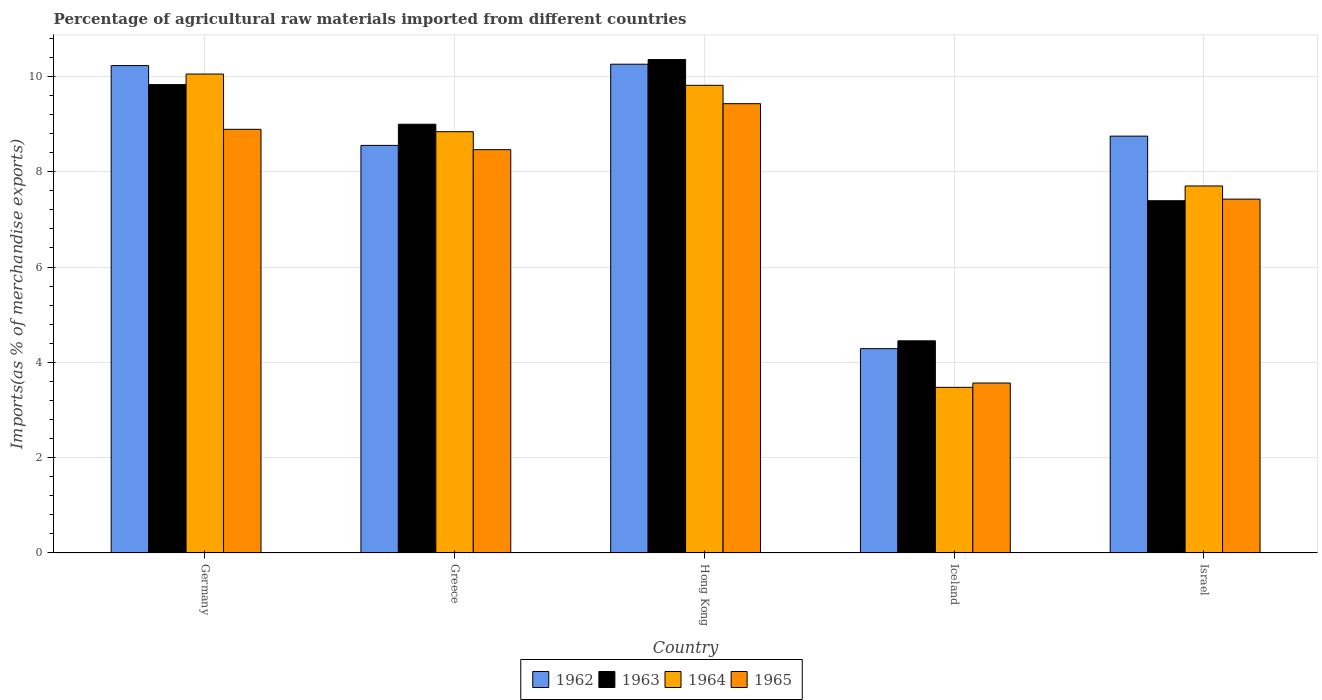How many groups of bars are there?
Keep it short and to the point. 5. How many bars are there on the 5th tick from the left?
Give a very brief answer. 4. What is the percentage of imports to different countries in 1964 in Israel?
Give a very brief answer. 7.7. Across all countries, what is the maximum percentage of imports to different countries in 1963?
Keep it short and to the point. 10.35. Across all countries, what is the minimum percentage of imports to different countries in 1965?
Provide a succinct answer. 3.57. In which country was the percentage of imports to different countries in 1965 maximum?
Keep it short and to the point. Hong Kong. What is the total percentage of imports to different countries in 1964 in the graph?
Keep it short and to the point. 39.88. What is the difference between the percentage of imports to different countries in 1965 in Greece and that in Iceland?
Offer a very short reply. 4.9. What is the difference between the percentage of imports to different countries in 1962 in Israel and the percentage of imports to different countries in 1964 in Hong Kong?
Provide a short and direct response. -1.07. What is the average percentage of imports to different countries in 1963 per country?
Offer a terse response. 8.2. What is the difference between the percentage of imports to different countries of/in 1962 and percentage of imports to different countries of/in 1964 in Germany?
Your answer should be compact. 0.18. What is the ratio of the percentage of imports to different countries in 1963 in Germany to that in Hong Kong?
Ensure brevity in your answer.  0.95. Is the difference between the percentage of imports to different countries in 1962 in Greece and Hong Kong greater than the difference between the percentage of imports to different countries in 1964 in Greece and Hong Kong?
Offer a very short reply. No. What is the difference between the highest and the second highest percentage of imports to different countries in 1964?
Offer a very short reply. -0.97. What is the difference between the highest and the lowest percentage of imports to different countries in 1962?
Make the answer very short. 5.97. In how many countries, is the percentage of imports to different countries in 1965 greater than the average percentage of imports to different countries in 1965 taken over all countries?
Provide a short and direct response. 3. Is the sum of the percentage of imports to different countries in 1965 in Greece and Hong Kong greater than the maximum percentage of imports to different countries in 1962 across all countries?
Give a very brief answer. Yes. Is it the case that in every country, the sum of the percentage of imports to different countries in 1965 and percentage of imports to different countries in 1962 is greater than the percentage of imports to different countries in 1963?
Provide a succinct answer. Yes. What is the title of the graph?
Offer a terse response. Percentage of agricultural raw materials imported from different countries. Does "1962" appear as one of the legend labels in the graph?
Your answer should be compact. Yes. What is the label or title of the X-axis?
Offer a terse response. Country. What is the label or title of the Y-axis?
Give a very brief answer. Imports(as % of merchandise exports). What is the Imports(as % of merchandise exports) in 1962 in Germany?
Keep it short and to the point. 10.23. What is the Imports(as % of merchandise exports) of 1963 in Germany?
Ensure brevity in your answer.  9.83. What is the Imports(as % of merchandise exports) of 1964 in Germany?
Provide a short and direct response. 10.05. What is the Imports(as % of merchandise exports) in 1965 in Germany?
Offer a very short reply. 8.89. What is the Imports(as % of merchandise exports) in 1962 in Greece?
Your answer should be very brief. 8.55. What is the Imports(as % of merchandise exports) of 1963 in Greece?
Keep it short and to the point. 9. What is the Imports(as % of merchandise exports) of 1964 in Greece?
Offer a terse response. 8.84. What is the Imports(as % of merchandise exports) of 1965 in Greece?
Make the answer very short. 8.46. What is the Imports(as % of merchandise exports) in 1962 in Hong Kong?
Provide a succinct answer. 10.26. What is the Imports(as % of merchandise exports) in 1963 in Hong Kong?
Provide a succinct answer. 10.35. What is the Imports(as % of merchandise exports) in 1964 in Hong Kong?
Offer a terse response. 9.81. What is the Imports(as % of merchandise exports) in 1965 in Hong Kong?
Your answer should be compact. 9.43. What is the Imports(as % of merchandise exports) in 1962 in Iceland?
Your response must be concise. 4.29. What is the Imports(as % of merchandise exports) of 1963 in Iceland?
Offer a very short reply. 4.45. What is the Imports(as % of merchandise exports) of 1964 in Iceland?
Provide a succinct answer. 3.48. What is the Imports(as % of merchandise exports) in 1965 in Iceland?
Offer a very short reply. 3.57. What is the Imports(as % of merchandise exports) of 1962 in Israel?
Offer a very short reply. 8.75. What is the Imports(as % of merchandise exports) of 1963 in Israel?
Offer a terse response. 7.39. What is the Imports(as % of merchandise exports) in 1964 in Israel?
Your answer should be compact. 7.7. What is the Imports(as % of merchandise exports) in 1965 in Israel?
Ensure brevity in your answer.  7.42. Across all countries, what is the maximum Imports(as % of merchandise exports) in 1962?
Provide a succinct answer. 10.26. Across all countries, what is the maximum Imports(as % of merchandise exports) in 1963?
Keep it short and to the point. 10.35. Across all countries, what is the maximum Imports(as % of merchandise exports) of 1964?
Provide a succinct answer. 10.05. Across all countries, what is the maximum Imports(as % of merchandise exports) in 1965?
Give a very brief answer. 9.43. Across all countries, what is the minimum Imports(as % of merchandise exports) in 1962?
Provide a short and direct response. 4.29. Across all countries, what is the minimum Imports(as % of merchandise exports) of 1963?
Give a very brief answer. 4.45. Across all countries, what is the minimum Imports(as % of merchandise exports) in 1964?
Offer a terse response. 3.48. Across all countries, what is the minimum Imports(as % of merchandise exports) of 1965?
Your answer should be compact. 3.57. What is the total Imports(as % of merchandise exports) in 1962 in the graph?
Offer a terse response. 42.07. What is the total Imports(as % of merchandise exports) of 1963 in the graph?
Offer a terse response. 41.02. What is the total Imports(as % of merchandise exports) of 1964 in the graph?
Offer a terse response. 39.88. What is the total Imports(as % of merchandise exports) in 1965 in the graph?
Your answer should be compact. 37.77. What is the difference between the Imports(as % of merchandise exports) of 1962 in Germany and that in Greece?
Provide a short and direct response. 1.67. What is the difference between the Imports(as % of merchandise exports) of 1963 in Germany and that in Greece?
Provide a short and direct response. 0.83. What is the difference between the Imports(as % of merchandise exports) of 1964 in Germany and that in Greece?
Offer a very short reply. 1.21. What is the difference between the Imports(as % of merchandise exports) in 1965 in Germany and that in Greece?
Ensure brevity in your answer.  0.43. What is the difference between the Imports(as % of merchandise exports) in 1962 in Germany and that in Hong Kong?
Offer a very short reply. -0.03. What is the difference between the Imports(as % of merchandise exports) in 1963 in Germany and that in Hong Kong?
Offer a very short reply. -0.53. What is the difference between the Imports(as % of merchandise exports) of 1964 in Germany and that in Hong Kong?
Offer a terse response. 0.24. What is the difference between the Imports(as % of merchandise exports) in 1965 in Germany and that in Hong Kong?
Provide a succinct answer. -0.54. What is the difference between the Imports(as % of merchandise exports) of 1962 in Germany and that in Iceland?
Give a very brief answer. 5.94. What is the difference between the Imports(as % of merchandise exports) in 1963 in Germany and that in Iceland?
Your answer should be very brief. 5.38. What is the difference between the Imports(as % of merchandise exports) of 1964 in Germany and that in Iceland?
Your answer should be very brief. 6.57. What is the difference between the Imports(as % of merchandise exports) of 1965 in Germany and that in Iceland?
Offer a very short reply. 5.32. What is the difference between the Imports(as % of merchandise exports) of 1962 in Germany and that in Israel?
Provide a succinct answer. 1.48. What is the difference between the Imports(as % of merchandise exports) of 1963 in Germany and that in Israel?
Offer a very short reply. 2.44. What is the difference between the Imports(as % of merchandise exports) of 1964 in Germany and that in Israel?
Provide a succinct answer. 2.35. What is the difference between the Imports(as % of merchandise exports) in 1965 in Germany and that in Israel?
Offer a terse response. 1.46. What is the difference between the Imports(as % of merchandise exports) in 1962 in Greece and that in Hong Kong?
Give a very brief answer. -1.7. What is the difference between the Imports(as % of merchandise exports) in 1963 in Greece and that in Hong Kong?
Your answer should be very brief. -1.36. What is the difference between the Imports(as % of merchandise exports) in 1964 in Greece and that in Hong Kong?
Offer a very short reply. -0.97. What is the difference between the Imports(as % of merchandise exports) in 1965 in Greece and that in Hong Kong?
Your answer should be very brief. -0.96. What is the difference between the Imports(as % of merchandise exports) in 1962 in Greece and that in Iceland?
Keep it short and to the point. 4.26. What is the difference between the Imports(as % of merchandise exports) of 1963 in Greece and that in Iceland?
Your answer should be compact. 4.54. What is the difference between the Imports(as % of merchandise exports) in 1964 in Greece and that in Iceland?
Make the answer very short. 5.36. What is the difference between the Imports(as % of merchandise exports) of 1965 in Greece and that in Iceland?
Offer a very short reply. 4.9. What is the difference between the Imports(as % of merchandise exports) of 1962 in Greece and that in Israel?
Make the answer very short. -0.19. What is the difference between the Imports(as % of merchandise exports) in 1963 in Greece and that in Israel?
Provide a succinct answer. 1.6. What is the difference between the Imports(as % of merchandise exports) in 1964 in Greece and that in Israel?
Your answer should be very brief. 1.14. What is the difference between the Imports(as % of merchandise exports) in 1965 in Greece and that in Israel?
Provide a short and direct response. 1.04. What is the difference between the Imports(as % of merchandise exports) in 1962 in Hong Kong and that in Iceland?
Offer a very short reply. 5.97. What is the difference between the Imports(as % of merchandise exports) in 1963 in Hong Kong and that in Iceland?
Offer a very short reply. 5.9. What is the difference between the Imports(as % of merchandise exports) of 1964 in Hong Kong and that in Iceland?
Your response must be concise. 6.34. What is the difference between the Imports(as % of merchandise exports) in 1965 in Hong Kong and that in Iceland?
Provide a short and direct response. 5.86. What is the difference between the Imports(as % of merchandise exports) in 1962 in Hong Kong and that in Israel?
Keep it short and to the point. 1.51. What is the difference between the Imports(as % of merchandise exports) of 1963 in Hong Kong and that in Israel?
Provide a short and direct response. 2.96. What is the difference between the Imports(as % of merchandise exports) of 1964 in Hong Kong and that in Israel?
Offer a terse response. 2.11. What is the difference between the Imports(as % of merchandise exports) in 1965 in Hong Kong and that in Israel?
Your response must be concise. 2. What is the difference between the Imports(as % of merchandise exports) in 1962 in Iceland and that in Israel?
Give a very brief answer. -4.46. What is the difference between the Imports(as % of merchandise exports) in 1963 in Iceland and that in Israel?
Keep it short and to the point. -2.94. What is the difference between the Imports(as % of merchandise exports) of 1964 in Iceland and that in Israel?
Give a very brief answer. -4.23. What is the difference between the Imports(as % of merchandise exports) of 1965 in Iceland and that in Israel?
Your response must be concise. -3.86. What is the difference between the Imports(as % of merchandise exports) in 1962 in Germany and the Imports(as % of merchandise exports) in 1963 in Greece?
Your answer should be compact. 1.23. What is the difference between the Imports(as % of merchandise exports) of 1962 in Germany and the Imports(as % of merchandise exports) of 1964 in Greece?
Offer a terse response. 1.39. What is the difference between the Imports(as % of merchandise exports) of 1962 in Germany and the Imports(as % of merchandise exports) of 1965 in Greece?
Provide a short and direct response. 1.76. What is the difference between the Imports(as % of merchandise exports) of 1963 in Germany and the Imports(as % of merchandise exports) of 1965 in Greece?
Your answer should be very brief. 1.36. What is the difference between the Imports(as % of merchandise exports) of 1964 in Germany and the Imports(as % of merchandise exports) of 1965 in Greece?
Ensure brevity in your answer.  1.59. What is the difference between the Imports(as % of merchandise exports) in 1962 in Germany and the Imports(as % of merchandise exports) in 1963 in Hong Kong?
Provide a succinct answer. -0.13. What is the difference between the Imports(as % of merchandise exports) in 1962 in Germany and the Imports(as % of merchandise exports) in 1964 in Hong Kong?
Provide a succinct answer. 0.41. What is the difference between the Imports(as % of merchandise exports) of 1962 in Germany and the Imports(as % of merchandise exports) of 1965 in Hong Kong?
Keep it short and to the point. 0.8. What is the difference between the Imports(as % of merchandise exports) in 1963 in Germany and the Imports(as % of merchandise exports) in 1964 in Hong Kong?
Offer a terse response. 0.01. What is the difference between the Imports(as % of merchandise exports) of 1963 in Germany and the Imports(as % of merchandise exports) of 1965 in Hong Kong?
Offer a very short reply. 0.4. What is the difference between the Imports(as % of merchandise exports) in 1964 in Germany and the Imports(as % of merchandise exports) in 1965 in Hong Kong?
Give a very brief answer. 0.62. What is the difference between the Imports(as % of merchandise exports) in 1962 in Germany and the Imports(as % of merchandise exports) in 1963 in Iceland?
Give a very brief answer. 5.77. What is the difference between the Imports(as % of merchandise exports) in 1962 in Germany and the Imports(as % of merchandise exports) in 1964 in Iceland?
Provide a short and direct response. 6.75. What is the difference between the Imports(as % of merchandise exports) of 1962 in Germany and the Imports(as % of merchandise exports) of 1965 in Iceland?
Provide a succinct answer. 6.66. What is the difference between the Imports(as % of merchandise exports) of 1963 in Germany and the Imports(as % of merchandise exports) of 1964 in Iceland?
Your answer should be very brief. 6.35. What is the difference between the Imports(as % of merchandise exports) in 1963 in Germany and the Imports(as % of merchandise exports) in 1965 in Iceland?
Your response must be concise. 6.26. What is the difference between the Imports(as % of merchandise exports) in 1964 in Germany and the Imports(as % of merchandise exports) in 1965 in Iceland?
Offer a very short reply. 6.48. What is the difference between the Imports(as % of merchandise exports) in 1962 in Germany and the Imports(as % of merchandise exports) in 1963 in Israel?
Offer a terse response. 2.84. What is the difference between the Imports(as % of merchandise exports) in 1962 in Germany and the Imports(as % of merchandise exports) in 1964 in Israel?
Make the answer very short. 2.53. What is the difference between the Imports(as % of merchandise exports) in 1962 in Germany and the Imports(as % of merchandise exports) in 1965 in Israel?
Provide a short and direct response. 2.8. What is the difference between the Imports(as % of merchandise exports) of 1963 in Germany and the Imports(as % of merchandise exports) of 1964 in Israel?
Provide a succinct answer. 2.13. What is the difference between the Imports(as % of merchandise exports) in 1963 in Germany and the Imports(as % of merchandise exports) in 1965 in Israel?
Offer a terse response. 2.4. What is the difference between the Imports(as % of merchandise exports) of 1964 in Germany and the Imports(as % of merchandise exports) of 1965 in Israel?
Provide a succinct answer. 2.62. What is the difference between the Imports(as % of merchandise exports) in 1962 in Greece and the Imports(as % of merchandise exports) in 1963 in Hong Kong?
Provide a short and direct response. -1.8. What is the difference between the Imports(as % of merchandise exports) in 1962 in Greece and the Imports(as % of merchandise exports) in 1964 in Hong Kong?
Offer a terse response. -1.26. What is the difference between the Imports(as % of merchandise exports) of 1962 in Greece and the Imports(as % of merchandise exports) of 1965 in Hong Kong?
Your response must be concise. -0.88. What is the difference between the Imports(as % of merchandise exports) of 1963 in Greece and the Imports(as % of merchandise exports) of 1964 in Hong Kong?
Offer a terse response. -0.82. What is the difference between the Imports(as % of merchandise exports) in 1963 in Greece and the Imports(as % of merchandise exports) in 1965 in Hong Kong?
Your response must be concise. -0.43. What is the difference between the Imports(as % of merchandise exports) of 1964 in Greece and the Imports(as % of merchandise exports) of 1965 in Hong Kong?
Make the answer very short. -0.59. What is the difference between the Imports(as % of merchandise exports) of 1962 in Greece and the Imports(as % of merchandise exports) of 1963 in Iceland?
Ensure brevity in your answer.  4.1. What is the difference between the Imports(as % of merchandise exports) in 1962 in Greece and the Imports(as % of merchandise exports) in 1964 in Iceland?
Offer a very short reply. 5.08. What is the difference between the Imports(as % of merchandise exports) in 1962 in Greece and the Imports(as % of merchandise exports) in 1965 in Iceland?
Provide a succinct answer. 4.99. What is the difference between the Imports(as % of merchandise exports) of 1963 in Greece and the Imports(as % of merchandise exports) of 1964 in Iceland?
Provide a succinct answer. 5.52. What is the difference between the Imports(as % of merchandise exports) of 1963 in Greece and the Imports(as % of merchandise exports) of 1965 in Iceland?
Offer a terse response. 5.43. What is the difference between the Imports(as % of merchandise exports) in 1964 in Greece and the Imports(as % of merchandise exports) in 1965 in Iceland?
Your answer should be very brief. 5.27. What is the difference between the Imports(as % of merchandise exports) in 1962 in Greece and the Imports(as % of merchandise exports) in 1963 in Israel?
Make the answer very short. 1.16. What is the difference between the Imports(as % of merchandise exports) in 1962 in Greece and the Imports(as % of merchandise exports) in 1964 in Israel?
Offer a very short reply. 0.85. What is the difference between the Imports(as % of merchandise exports) of 1962 in Greece and the Imports(as % of merchandise exports) of 1965 in Israel?
Give a very brief answer. 1.13. What is the difference between the Imports(as % of merchandise exports) in 1963 in Greece and the Imports(as % of merchandise exports) in 1964 in Israel?
Give a very brief answer. 1.3. What is the difference between the Imports(as % of merchandise exports) in 1963 in Greece and the Imports(as % of merchandise exports) in 1965 in Israel?
Your answer should be very brief. 1.57. What is the difference between the Imports(as % of merchandise exports) of 1964 in Greece and the Imports(as % of merchandise exports) of 1965 in Israel?
Ensure brevity in your answer.  1.42. What is the difference between the Imports(as % of merchandise exports) in 1962 in Hong Kong and the Imports(as % of merchandise exports) in 1963 in Iceland?
Your answer should be very brief. 5.8. What is the difference between the Imports(as % of merchandise exports) of 1962 in Hong Kong and the Imports(as % of merchandise exports) of 1964 in Iceland?
Your answer should be compact. 6.78. What is the difference between the Imports(as % of merchandise exports) of 1962 in Hong Kong and the Imports(as % of merchandise exports) of 1965 in Iceland?
Give a very brief answer. 6.69. What is the difference between the Imports(as % of merchandise exports) in 1963 in Hong Kong and the Imports(as % of merchandise exports) in 1964 in Iceland?
Keep it short and to the point. 6.88. What is the difference between the Imports(as % of merchandise exports) in 1963 in Hong Kong and the Imports(as % of merchandise exports) in 1965 in Iceland?
Offer a terse response. 6.79. What is the difference between the Imports(as % of merchandise exports) of 1964 in Hong Kong and the Imports(as % of merchandise exports) of 1965 in Iceland?
Ensure brevity in your answer.  6.25. What is the difference between the Imports(as % of merchandise exports) in 1962 in Hong Kong and the Imports(as % of merchandise exports) in 1963 in Israel?
Provide a succinct answer. 2.86. What is the difference between the Imports(as % of merchandise exports) in 1962 in Hong Kong and the Imports(as % of merchandise exports) in 1964 in Israel?
Your answer should be compact. 2.55. What is the difference between the Imports(as % of merchandise exports) of 1962 in Hong Kong and the Imports(as % of merchandise exports) of 1965 in Israel?
Provide a succinct answer. 2.83. What is the difference between the Imports(as % of merchandise exports) of 1963 in Hong Kong and the Imports(as % of merchandise exports) of 1964 in Israel?
Offer a terse response. 2.65. What is the difference between the Imports(as % of merchandise exports) of 1963 in Hong Kong and the Imports(as % of merchandise exports) of 1965 in Israel?
Keep it short and to the point. 2.93. What is the difference between the Imports(as % of merchandise exports) in 1964 in Hong Kong and the Imports(as % of merchandise exports) in 1965 in Israel?
Keep it short and to the point. 2.39. What is the difference between the Imports(as % of merchandise exports) of 1962 in Iceland and the Imports(as % of merchandise exports) of 1963 in Israel?
Provide a succinct answer. -3.1. What is the difference between the Imports(as % of merchandise exports) in 1962 in Iceland and the Imports(as % of merchandise exports) in 1964 in Israel?
Keep it short and to the point. -3.41. What is the difference between the Imports(as % of merchandise exports) of 1962 in Iceland and the Imports(as % of merchandise exports) of 1965 in Israel?
Offer a terse response. -3.14. What is the difference between the Imports(as % of merchandise exports) in 1963 in Iceland and the Imports(as % of merchandise exports) in 1964 in Israel?
Your answer should be compact. -3.25. What is the difference between the Imports(as % of merchandise exports) of 1963 in Iceland and the Imports(as % of merchandise exports) of 1965 in Israel?
Give a very brief answer. -2.97. What is the difference between the Imports(as % of merchandise exports) in 1964 in Iceland and the Imports(as % of merchandise exports) in 1965 in Israel?
Make the answer very short. -3.95. What is the average Imports(as % of merchandise exports) in 1962 per country?
Ensure brevity in your answer.  8.41. What is the average Imports(as % of merchandise exports) in 1963 per country?
Give a very brief answer. 8.2. What is the average Imports(as % of merchandise exports) of 1964 per country?
Offer a terse response. 7.98. What is the average Imports(as % of merchandise exports) in 1965 per country?
Ensure brevity in your answer.  7.55. What is the difference between the Imports(as % of merchandise exports) in 1962 and Imports(as % of merchandise exports) in 1963 in Germany?
Offer a terse response. 0.4. What is the difference between the Imports(as % of merchandise exports) in 1962 and Imports(as % of merchandise exports) in 1964 in Germany?
Your answer should be compact. 0.18. What is the difference between the Imports(as % of merchandise exports) of 1962 and Imports(as % of merchandise exports) of 1965 in Germany?
Offer a very short reply. 1.34. What is the difference between the Imports(as % of merchandise exports) in 1963 and Imports(as % of merchandise exports) in 1964 in Germany?
Your answer should be very brief. -0.22. What is the difference between the Imports(as % of merchandise exports) of 1963 and Imports(as % of merchandise exports) of 1965 in Germany?
Make the answer very short. 0.94. What is the difference between the Imports(as % of merchandise exports) of 1964 and Imports(as % of merchandise exports) of 1965 in Germany?
Offer a terse response. 1.16. What is the difference between the Imports(as % of merchandise exports) in 1962 and Imports(as % of merchandise exports) in 1963 in Greece?
Keep it short and to the point. -0.44. What is the difference between the Imports(as % of merchandise exports) in 1962 and Imports(as % of merchandise exports) in 1964 in Greece?
Give a very brief answer. -0.29. What is the difference between the Imports(as % of merchandise exports) in 1962 and Imports(as % of merchandise exports) in 1965 in Greece?
Your answer should be very brief. 0.09. What is the difference between the Imports(as % of merchandise exports) of 1963 and Imports(as % of merchandise exports) of 1964 in Greece?
Your answer should be very brief. 0.16. What is the difference between the Imports(as % of merchandise exports) of 1963 and Imports(as % of merchandise exports) of 1965 in Greece?
Your answer should be compact. 0.53. What is the difference between the Imports(as % of merchandise exports) of 1964 and Imports(as % of merchandise exports) of 1965 in Greece?
Ensure brevity in your answer.  0.38. What is the difference between the Imports(as % of merchandise exports) of 1962 and Imports(as % of merchandise exports) of 1963 in Hong Kong?
Your answer should be compact. -0.1. What is the difference between the Imports(as % of merchandise exports) of 1962 and Imports(as % of merchandise exports) of 1964 in Hong Kong?
Make the answer very short. 0.44. What is the difference between the Imports(as % of merchandise exports) of 1962 and Imports(as % of merchandise exports) of 1965 in Hong Kong?
Your answer should be very brief. 0.83. What is the difference between the Imports(as % of merchandise exports) in 1963 and Imports(as % of merchandise exports) in 1964 in Hong Kong?
Your answer should be very brief. 0.54. What is the difference between the Imports(as % of merchandise exports) in 1963 and Imports(as % of merchandise exports) in 1965 in Hong Kong?
Your answer should be compact. 0.93. What is the difference between the Imports(as % of merchandise exports) of 1964 and Imports(as % of merchandise exports) of 1965 in Hong Kong?
Your answer should be very brief. 0.39. What is the difference between the Imports(as % of merchandise exports) in 1962 and Imports(as % of merchandise exports) in 1963 in Iceland?
Offer a terse response. -0.16. What is the difference between the Imports(as % of merchandise exports) in 1962 and Imports(as % of merchandise exports) in 1964 in Iceland?
Make the answer very short. 0.81. What is the difference between the Imports(as % of merchandise exports) in 1962 and Imports(as % of merchandise exports) in 1965 in Iceland?
Provide a short and direct response. 0.72. What is the difference between the Imports(as % of merchandise exports) of 1963 and Imports(as % of merchandise exports) of 1964 in Iceland?
Offer a terse response. 0.98. What is the difference between the Imports(as % of merchandise exports) in 1963 and Imports(as % of merchandise exports) in 1965 in Iceland?
Make the answer very short. 0.89. What is the difference between the Imports(as % of merchandise exports) of 1964 and Imports(as % of merchandise exports) of 1965 in Iceland?
Provide a succinct answer. -0.09. What is the difference between the Imports(as % of merchandise exports) in 1962 and Imports(as % of merchandise exports) in 1963 in Israel?
Give a very brief answer. 1.36. What is the difference between the Imports(as % of merchandise exports) in 1962 and Imports(as % of merchandise exports) in 1964 in Israel?
Your answer should be very brief. 1.05. What is the difference between the Imports(as % of merchandise exports) of 1962 and Imports(as % of merchandise exports) of 1965 in Israel?
Offer a terse response. 1.32. What is the difference between the Imports(as % of merchandise exports) of 1963 and Imports(as % of merchandise exports) of 1964 in Israel?
Your answer should be very brief. -0.31. What is the difference between the Imports(as % of merchandise exports) of 1963 and Imports(as % of merchandise exports) of 1965 in Israel?
Give a very brief answer. -0.03. What is the difference between the Imports(as % of merchandise exports) of 1964 and Imports(as % of merchandise exports) of 1965 in Israel?
Provide a succinct answer. 0.28. What is the ratio of the Imports(as % of merchandise exports) in 1962 in Germany to that in Greece?
Your answer should be very brief. 1.2. What is the ratio of the Imports(as % of merchandise exports) of 1963 in Germany to that in Greece?
Your answer should be very brief. 1.09. What is the ratio of the Imports(as % of merchandise exports) in 1964 in Germany to that in Greece?
Keep it short and to the point. 1.14. What is the ratio of the Imports(as % of merchandise exports) of 1965 in Germany to that in Greece?
Keep it short and to the point. 1.05. What is the ratio of the Imports(as % of merchandise exports) of 1963 in Germany to that in Hong Kong?
Ensure brevity in your answer.  0.95. What is the ratio of the Imports(as % of merchandise exports) in 1964 in Germany to that in Hong Kong?
Offer a terse response. 1.02. What is the ratio of the Imports(as % of merchandise exports) in 1965 in Germany to that in Hong Kong?
Ensure brevity in your answer.  0.94. What is the ratio of the Imports(as % of merchandise exports) of 1962 in Germany to that in Iceland?
Your answer should be compact. 2.39. What is the ratio of the Imports(as % of merchandise exports) in 1963 in Germany to that in Iceland?
Offer a very short reply. 2.21. What is the ratio of the Imports(as % of merchandise exports) in 1964 in Germany to that in Iceland?
Give a very brief answer. 2.89. What is the ratio of the Imports(as % of merchandise exports) in 1965 in Germany to that in Iceland?
Give a very brief answer. 2.49. What is the ratio of the Imports(as % of merchandise exports) of 1962 in Germany to that in Israel?
Your answer should be very brief. 1.17. What is the ratio of the Imports(as % of merchandise exports) in 1963 in Germany to that in Israel?
Give a very brief answer. 1.33. What is the ratio of the Imports(as % of merchandise exports) of 1964 in Germany to that in Israel?
Your response must be concise. 1.3. What is the ratio of the Imports(as % of merchandise exports) of 1965 in Germany to that in Israel?
Make the answer very short. 1.2. What is the ratio of the Imports(as % of merchandise exports) of 1962 in Greece to that in Hong Kong?
Offer a terse response. 0.83. What is the ratio of the Imports(as % of merchandise exports) of 1963 in Greece to that in Hong Kong?
Provide a succinct answer. 0.87. What is the ratio of the Imports(as % of merchandise exports) in 1964 in Greece to that in Hong Kong?
Your answer should be compact. 0.9. What is the ratio of the Imports(as % of merchandise exports) in 1965 in Greece to that in Hong Kong?
Your answer should be compact. 0.9. What is the ratio of the Imports(as % of merchandise exports) in 1962 in Greece to that in Iceland?
Ensure brevity in your answer.  1.99. What is the ratio of the Imports(as % of merchandise exports) of 1963 in Greece to that in Iceland?
Provide a short and direct response. 2.02. What is the ratio of the Imports(as % of merchandise exports) in 1964 in Greece to that in Iceland?
Your response must be concise. 2.54. What is the ratio of the Imports(as % of merchandise exports) in 1965 in Greece to that in Iceland?
Offer a terse response. 2.37. What is the ratio of the Imports(as % of merchandise exports) of 1962 in Greece to that in Israel?
Give a very brief answer. 0.98. What is the ratio of the Imports(as % of merchandise exports) in 1963 in Greece to that in Israel?
Your answer should be very brief. 1.22. What is the ratio of the Imports(as % of merchandise exports) in 1964 in Greece to that in Israel?
Provide a short and direct response. 1.15. What is the ratio of the Imports(as % of merchandise exports) in 1965 in Greece to that in Israel?
Your answer should be compact. 1.14. What is the ratio of the Imports(as % of merchandise exports) in 1962 in Hong Kong to that in Iceland?
Your response must be concise. 2.39. What is the ratio of the Imports(as % of merchandise exports) in 1963 in Hong Kong to that in Iceland?
Offer a terse response. 2.33. What is the ratio of the Imports(as % of merchandise exports) of 1964 in Hong Kong to that in Iceland?
Provide a succinct answer. 2.82. What is the ratio of the Imports(as % of merchandise exports) of 1965 in Hong Kong to that in Iceland?
Offer a very short reply. 2.64. What is the ratio of the Imports(as % of merchandise exports) in 1962 in Hong Kong to that in Israel?
Ensure brevity in your answer.  1.17. What is the ratio of the Imports(as % of merchandise exports) of 1963 in Hong Kong to that in Israel?
Provide a succinct answer. 1.4. What is the ratio of the Imports(as % of merchandise exports) in 1964 in Hong Kong to that in Israel?
Offer a very short reply. 1.27. What is the ratio of the Imports(as % of merchandise exports) of 1965 in Hong Kong to that in Israel?
Make the answer very short. 1.27. What is the ratio of the Imports(as % of merchandise exports) in 1962 in Iceland to that in Israel?
Give a very brief answer. 0.49. What is the ratio of the Imports(as % of merchandise exports) in 1963 in Iceland to that in Israel?
Make the answer very short. 0.6. What is the ratio of the Imports(as % of merchandise exports) of 1964 in Iceland to that in Israel?
Your answer should be compact. 0.45. What is the ratio of the Imports(as % of merchandise exports) in 1965 in Iceland to that in Israel?
Your answer should be compact. 0.48. What is the difference between the highest and the second highest Imports(as % of merchandise exports) of 1962?
Offer a terse response. 0.03. What is the difference between the highest and the second highest Imports(as % of merchandise exports) in 1963?
Provide a succinct answer. 0.53. What is the difference between the highest and the second highest Imports(as % of merchandise exports) in 1964?
Make the answer very short. 0.24. What is the difference between the highest and the second highest Imports(as % of merchandise exports) in 1965?
Keep it short and to the point. 0.54. What is the difference between the highest and the lowest Imports(as % of merchandise exports) of 1962?
Provide a succinct answer. 5.97. What is the difference between the highest and the lowest Imports(as % of merchandise exports) in 1963?
Make the answer very short. 5.9. What is the difference between the highest and the lowest Imports(as % of merchandise exports) in 1964?
Your answer should be very brief. 6.57. What is the difference between the highest and the lowest Imports(as % of merchandise exports) of 1965?
Offer a terse response. 5.86. 